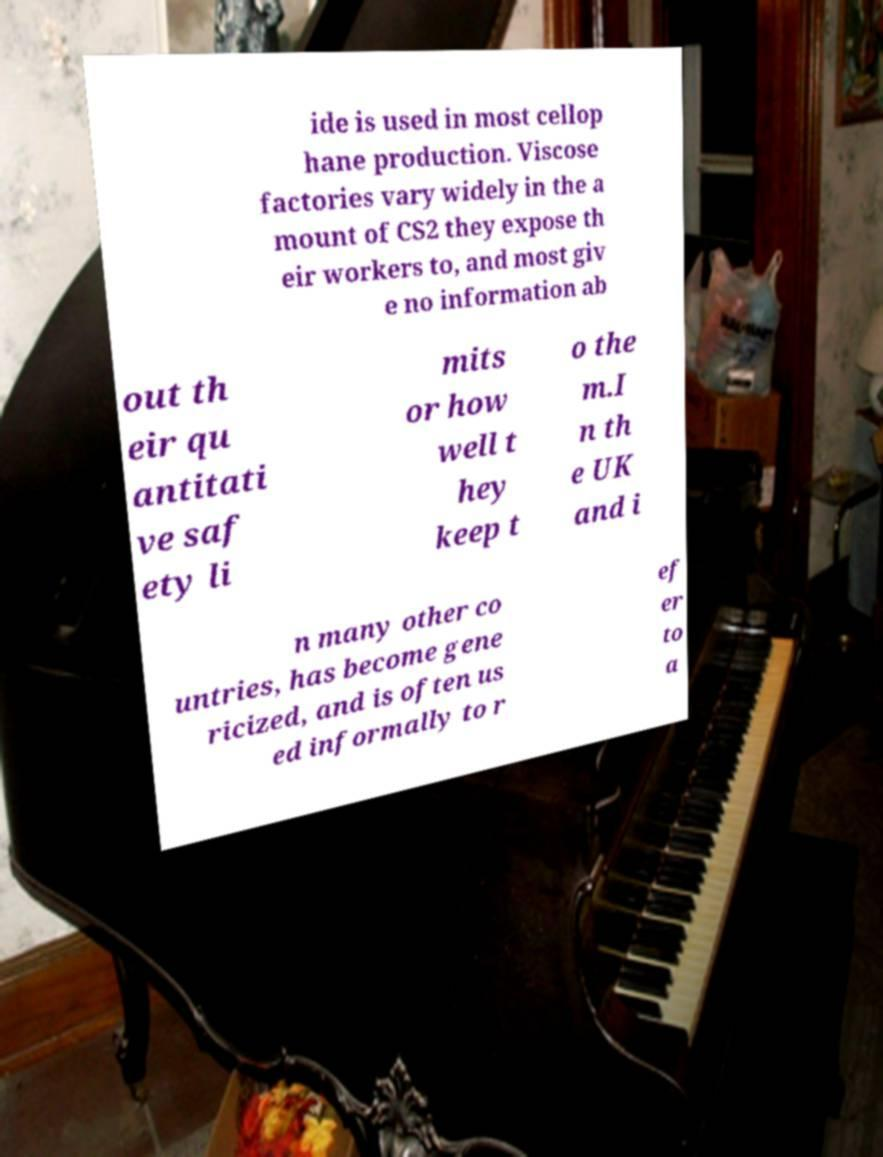For documentation purposes, I need the text within this image transcribed. Could you provide that? ide is used in most cellop hane production. Viscose factories vary widely in the a mount of CS2 they expose th eir workers to, and most giv e no information ab out th eir qu antitati ve saf ety li mits or how well t hey keep t o the m.I n th e UK and i n many other co untries, has become gene ricized, and is often us ed informally to r ef er to a 